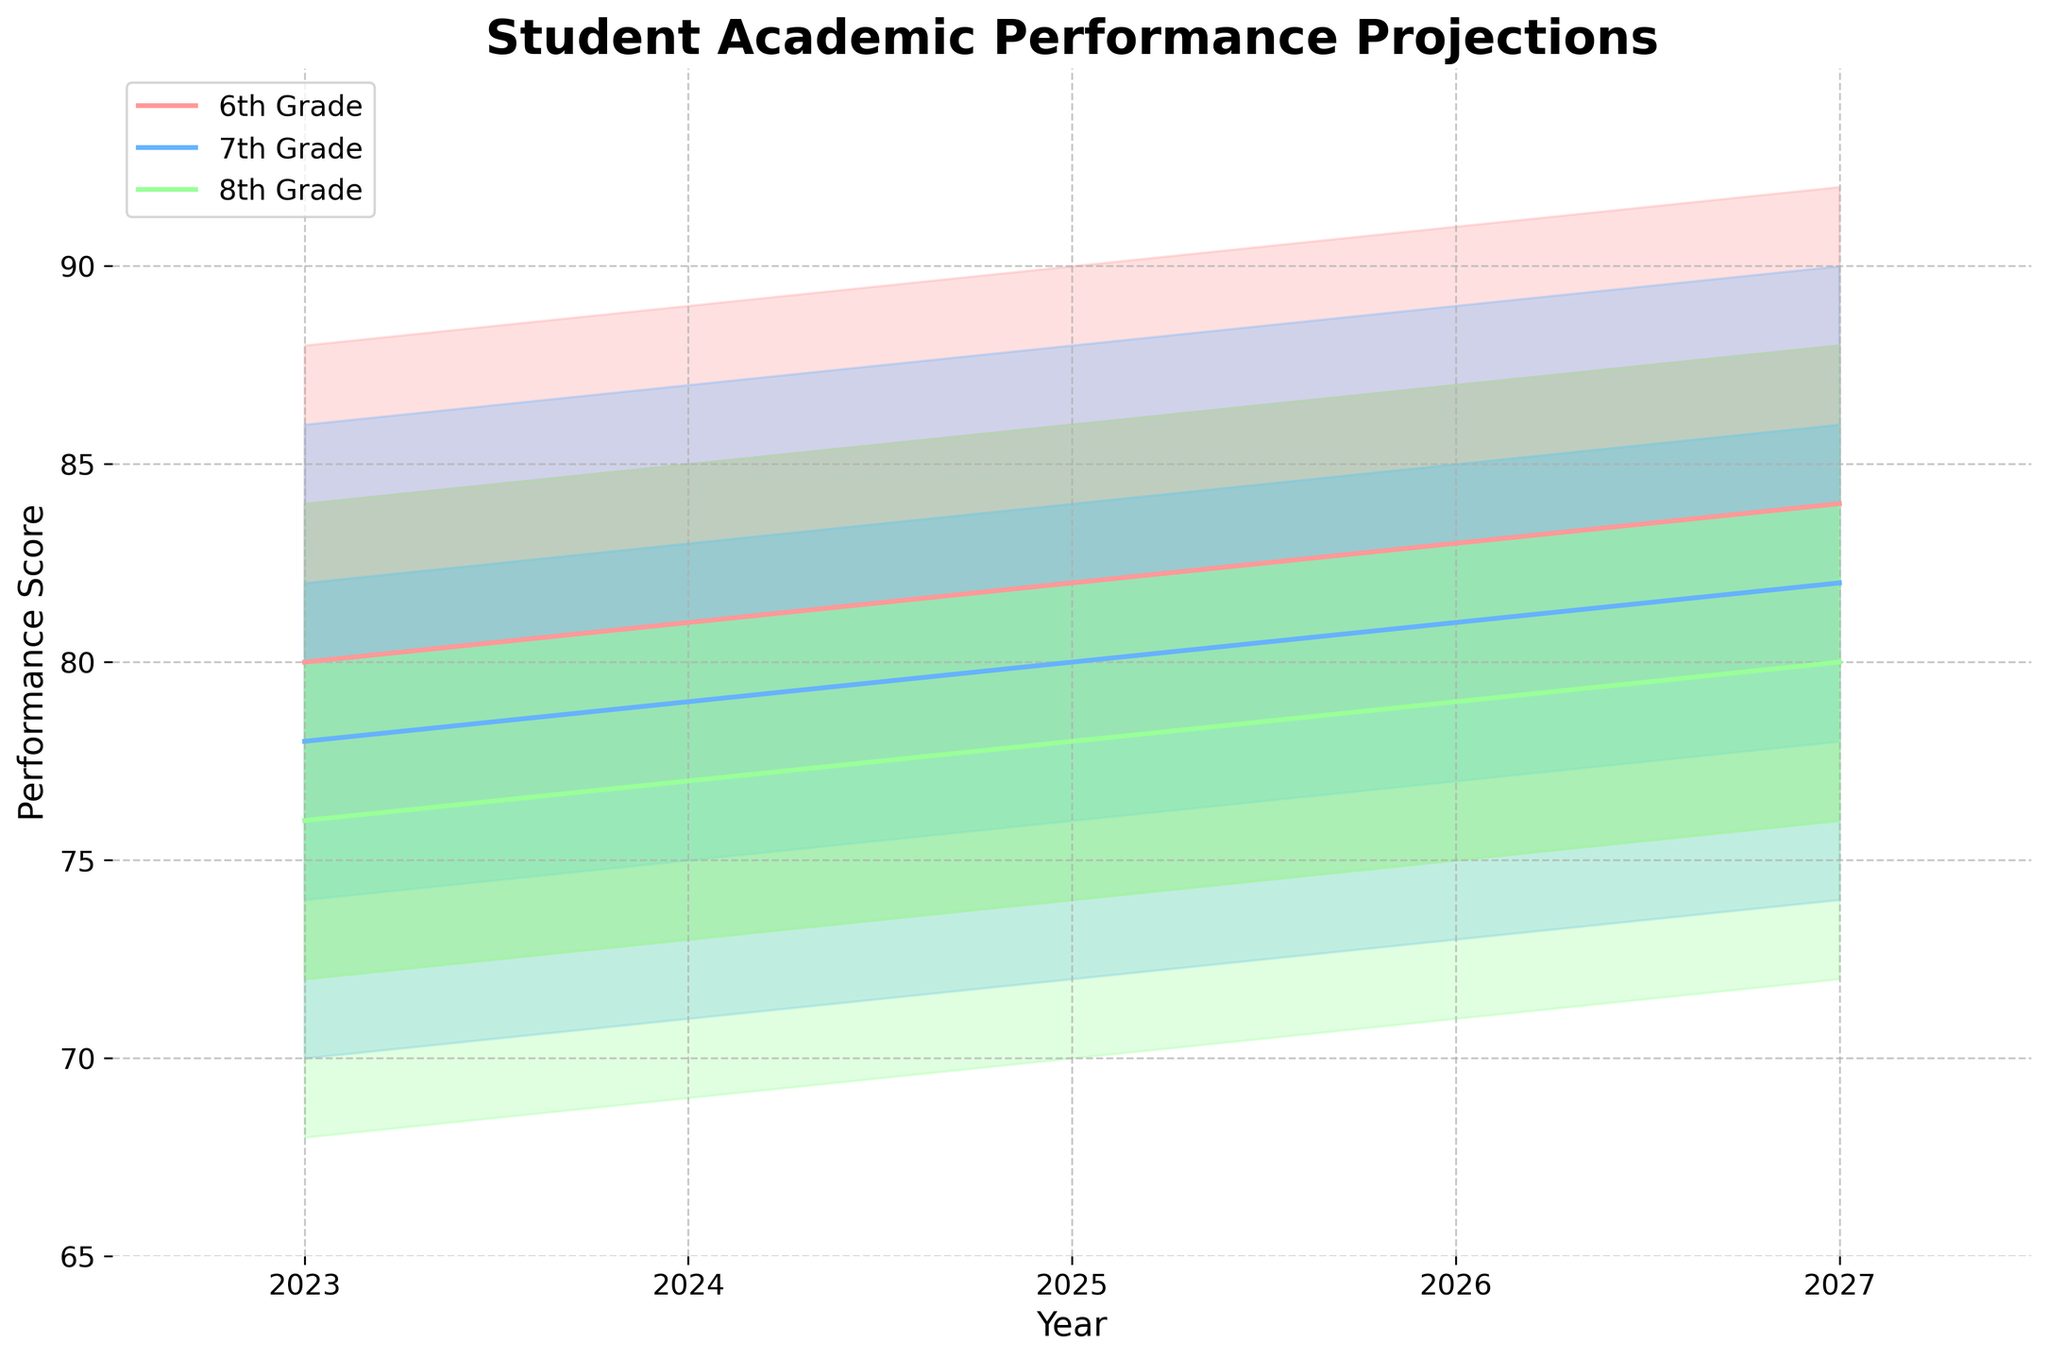What is the title of the figure? The title is located at the top of the figure and provides a clear indication of what the chart is about. It usually gives the viewer an immediate idea of the context.
Answer: Student Academic Performance Projections What are the variables plotted on the X and Y axes? The labels of the axes mention the variables measured. The X-axis typically represents the independent variable while the Y-axis shows the dependent variable.
Answer: X-axis: Year, Y-axis: Performance Score What do the different colors in the chart represent? The figure uses a color legend to inform the viewer about what the different colors signify. This helps in differentiating between the data groups being compared.
Answer: Different grade levels (6th Grade, 7th Grade, 8th Grade) What years are included in the projection? By examining the X-axis, we can determine the range of years for which the data is projected.
Answer: 2023 to 2027 Which grade level has the highest projected mid value in 2027? Locate 2027 on the X-axis and follow the projections upwards to find the middle value (Mid) for each grade level. Compare these mid values to find the highest one.
Answer: 6th Grade What is the range of performance scores for the 8th Grade in 2025? Find the data for 2025 on the X-axis for the 8th Grade and observe the areas of the fan chart corresponding to the low and high values.
Answer: 70 to 86 How does the projected mid value for the 6th Grade change from 2023 to 2027? Track the mid value for 6th Grade from 2023 to 2027 along the X-axis. Observe if it increases, decreases, or remains stable over these years.
Answer: Increases from 80 to 84 Which grade level shows the least variation in performance projections in 2024? Look at the spreads between the low and high values for each grade level in 2024. The grade with the smallest spread shows the least variation.
Answer: 8th Grade What is the average high value for the 7th Grade over the five years? Sum up the high values for the 7th Grade from 2023 to 2027 and divide by 5.
Answer: (86 + 87 + 88 + 89 + 90) / 5 = 88 What is the overall trend for the mid values for all grades from 2023 to 2027? Look at the mid values for each grade across the years from 2023 to 2027 to identify if there is a general increasing, decreasing, or stable trend.
Answer: Increasing trend 